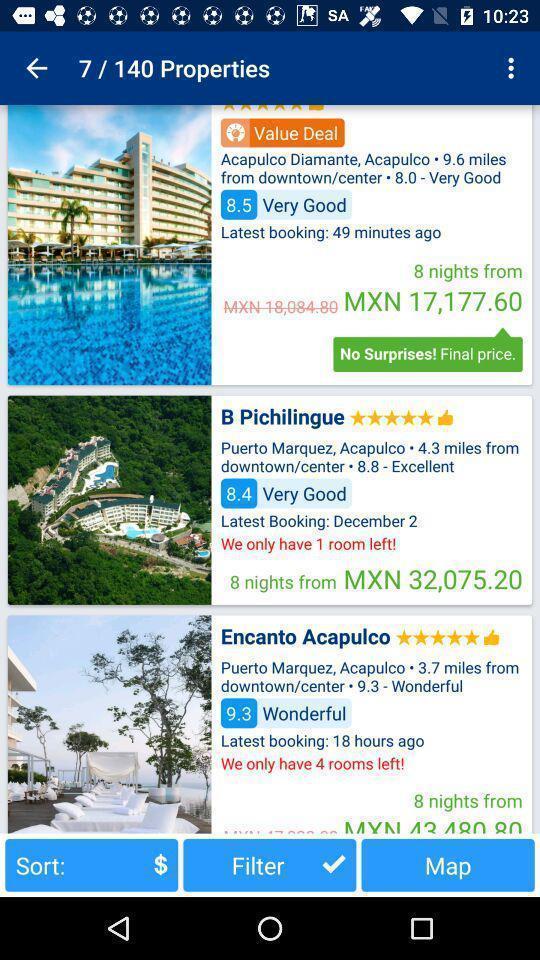Explain what's happening in this screen capture. Social app showing list of properties. 